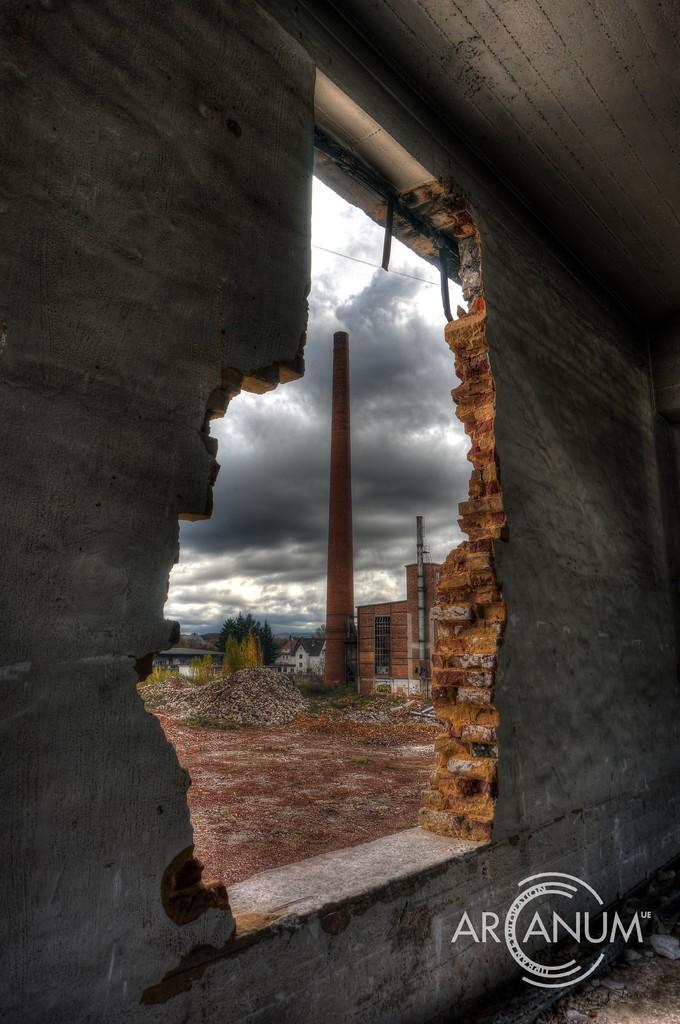Can you describe this image briefly? In the center of the image there is a wall, roof and a few other objects. At the bottom left side of the image, we can see some text. In the background, we can see the sky, clouds, buildings, one tower, one pole, trees, grass and a few other objects. 